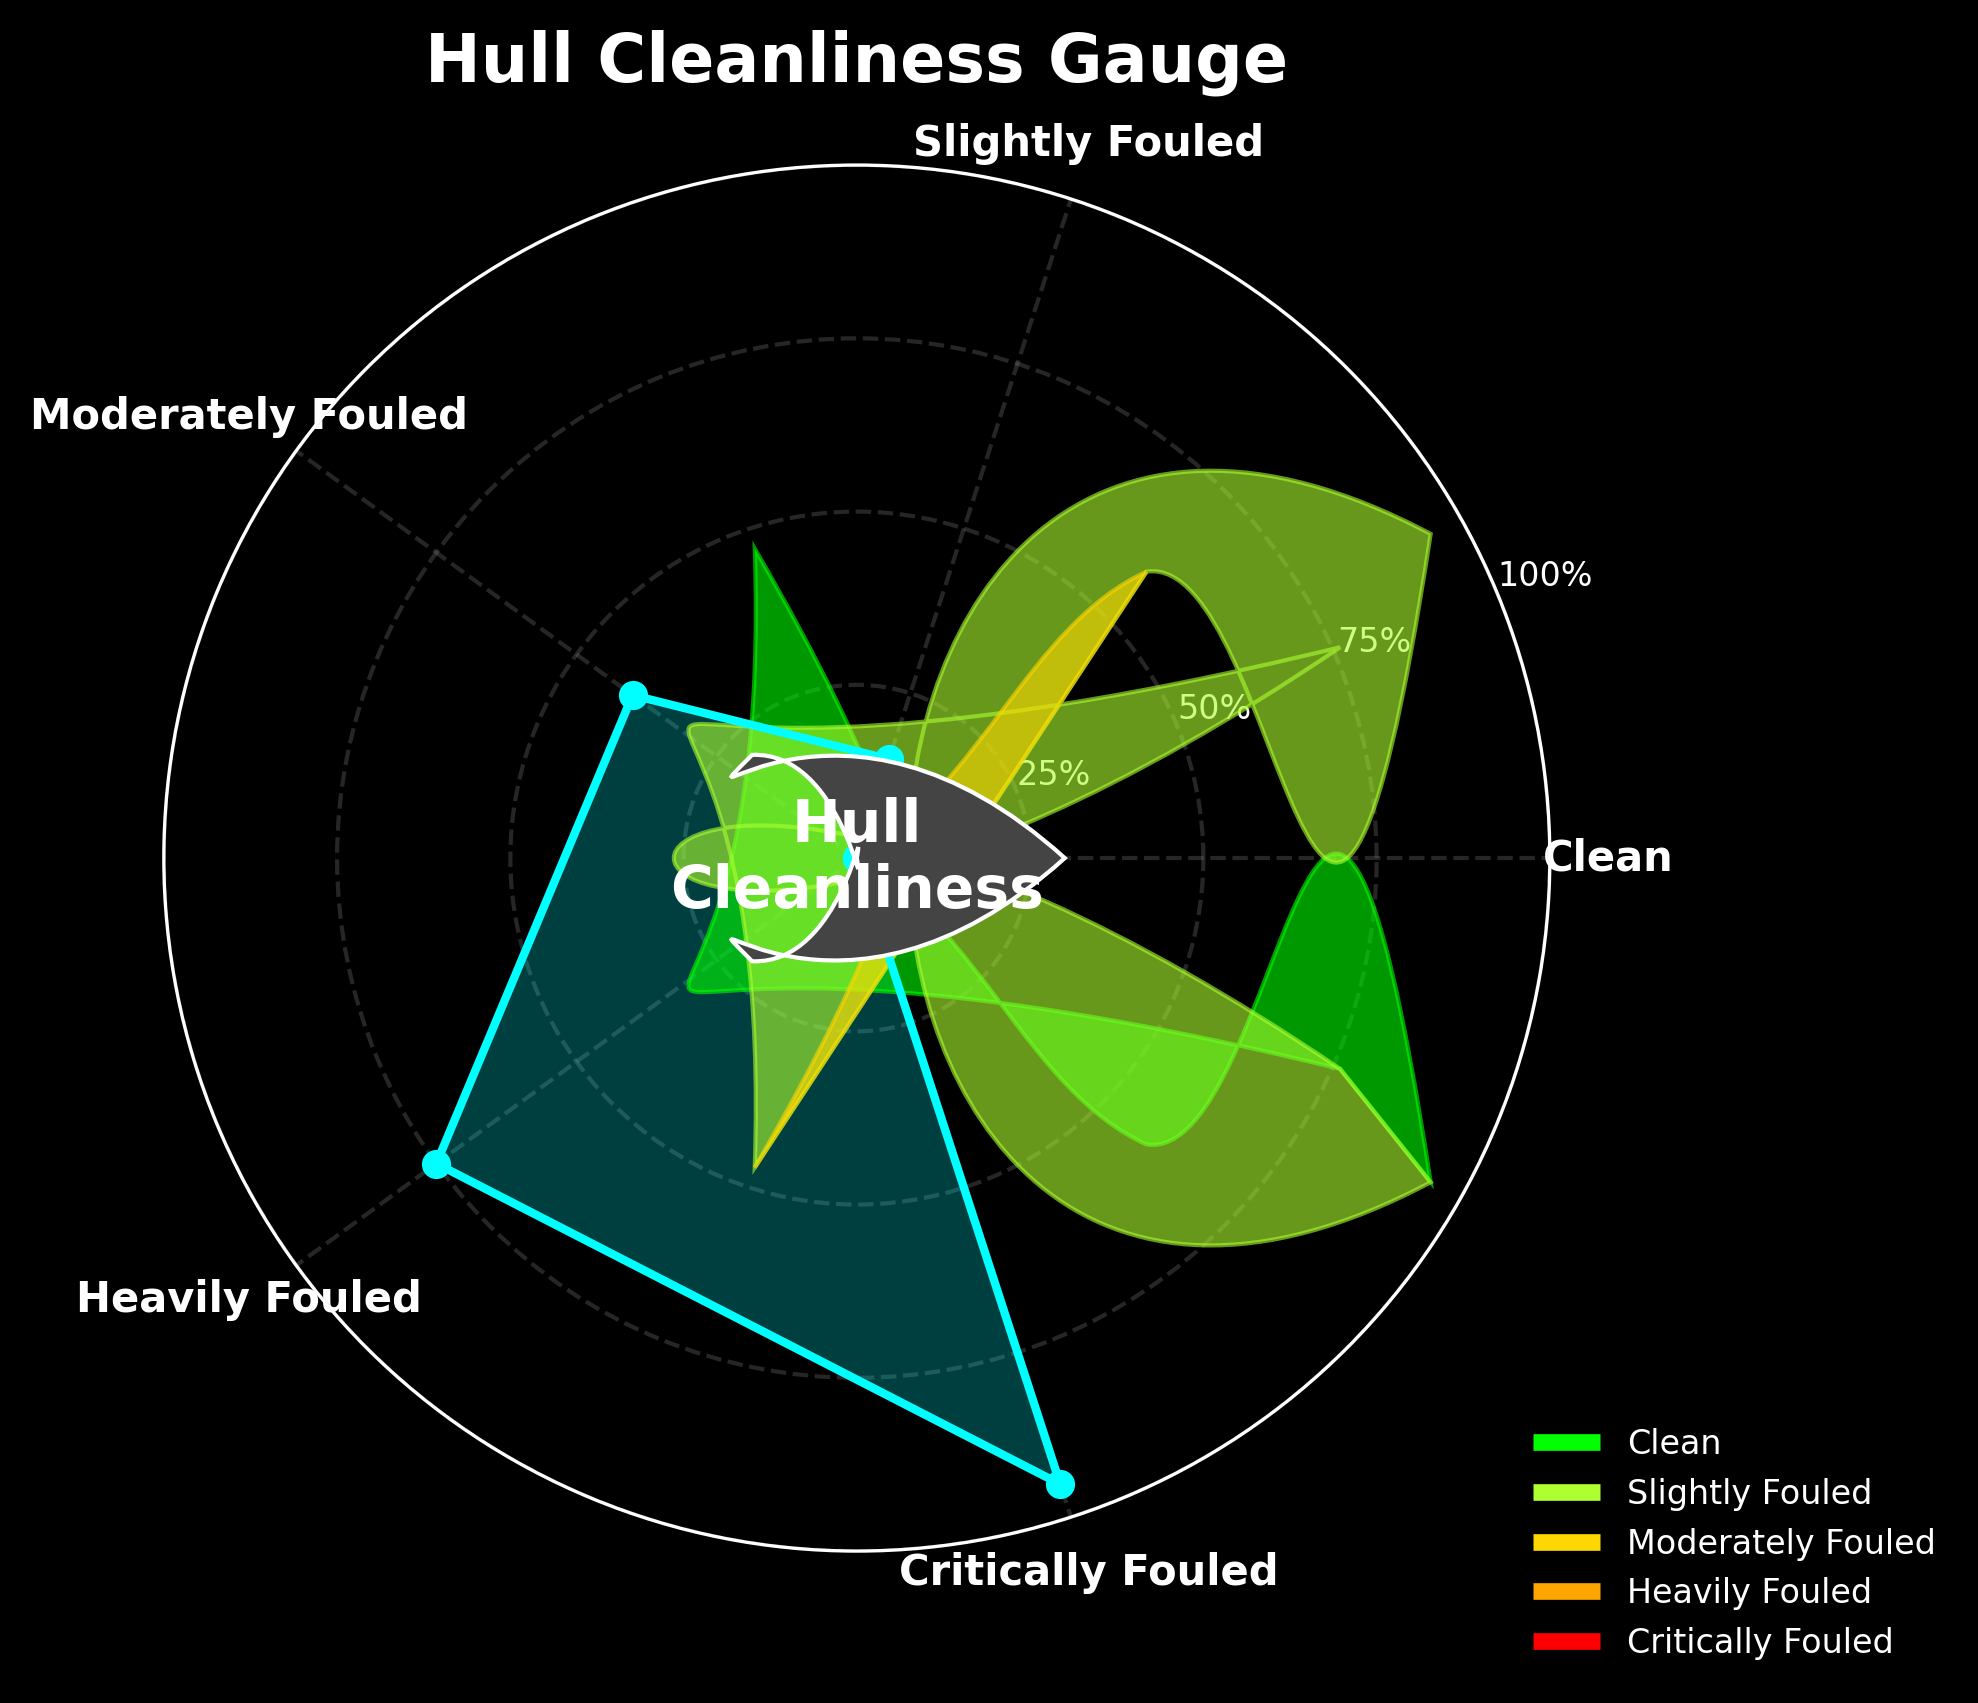What's the title of the figure? The title is usually displayed at the top of the figure. Here, it reads "Hull Cleanliness Gauge".
Answer: Hull Cleanliness Gauge What color represents the "Clean" category? By looking at the plot, the color near the label "Clean" represents the "Clean" category. It is green.
Answer: Green What are the radial labels shown in the plot? The radial labels are displayed along the radial axis of the gauge. They are 0%, 25%, 50%, 75%, and 100%.
Answer: 0%, 25%, 50%, 75%, 100% Which category has the highest growth percentage? The category with the highest growth percentage is at the end of the radial axis. Here, "Critically Fouled" shows 95%.
Answer: Critically Fouled How many different hull cleanliness categories are shown in the figure? By counting the number of categories around the plot, you can see there are 5 categories: Clean, Slightly Fouled, Moderately Fouled, Heavily Fouled, Critically Fouled.
Answer: 5 What is the difference in growth percentage between "Moderately Fouled" and "Heavily Fouled"? The growth percentage for "Moderately Fouled" is 40, and for "Heavily Fouled" it is 75. The difference is 75 - 40 = 35.
Answer: 35 Which category falls exactly in the middle in terms of the growth percentage? Sorting the percentages: 0, 15, 40, 75, 95, the middle value is 40, belonging to "Moderately Fouled".
Answer: Moderately Fouled By how much does the growth percentage in "Slightly Fouled" exceed that in "Clean"? "Slightly Fouled" has a growth percentage of 15, and "Clean" has 0. The difference is 15 - 0 = 15.
Answer: 15 Which categories have a growth percentage greater than 50%? Observing the radial plot, "Heavily Fouled" with 75% and "Critically Fouled" with 95% are above 50%.
Answer: Heavily Fouled, Critically Fouled What is the average growth percentage for all categories? To find the average: (0 + 15 + 40 + 75 + 95) / 5 = 225 / 5 = 45.
Answer: 45 